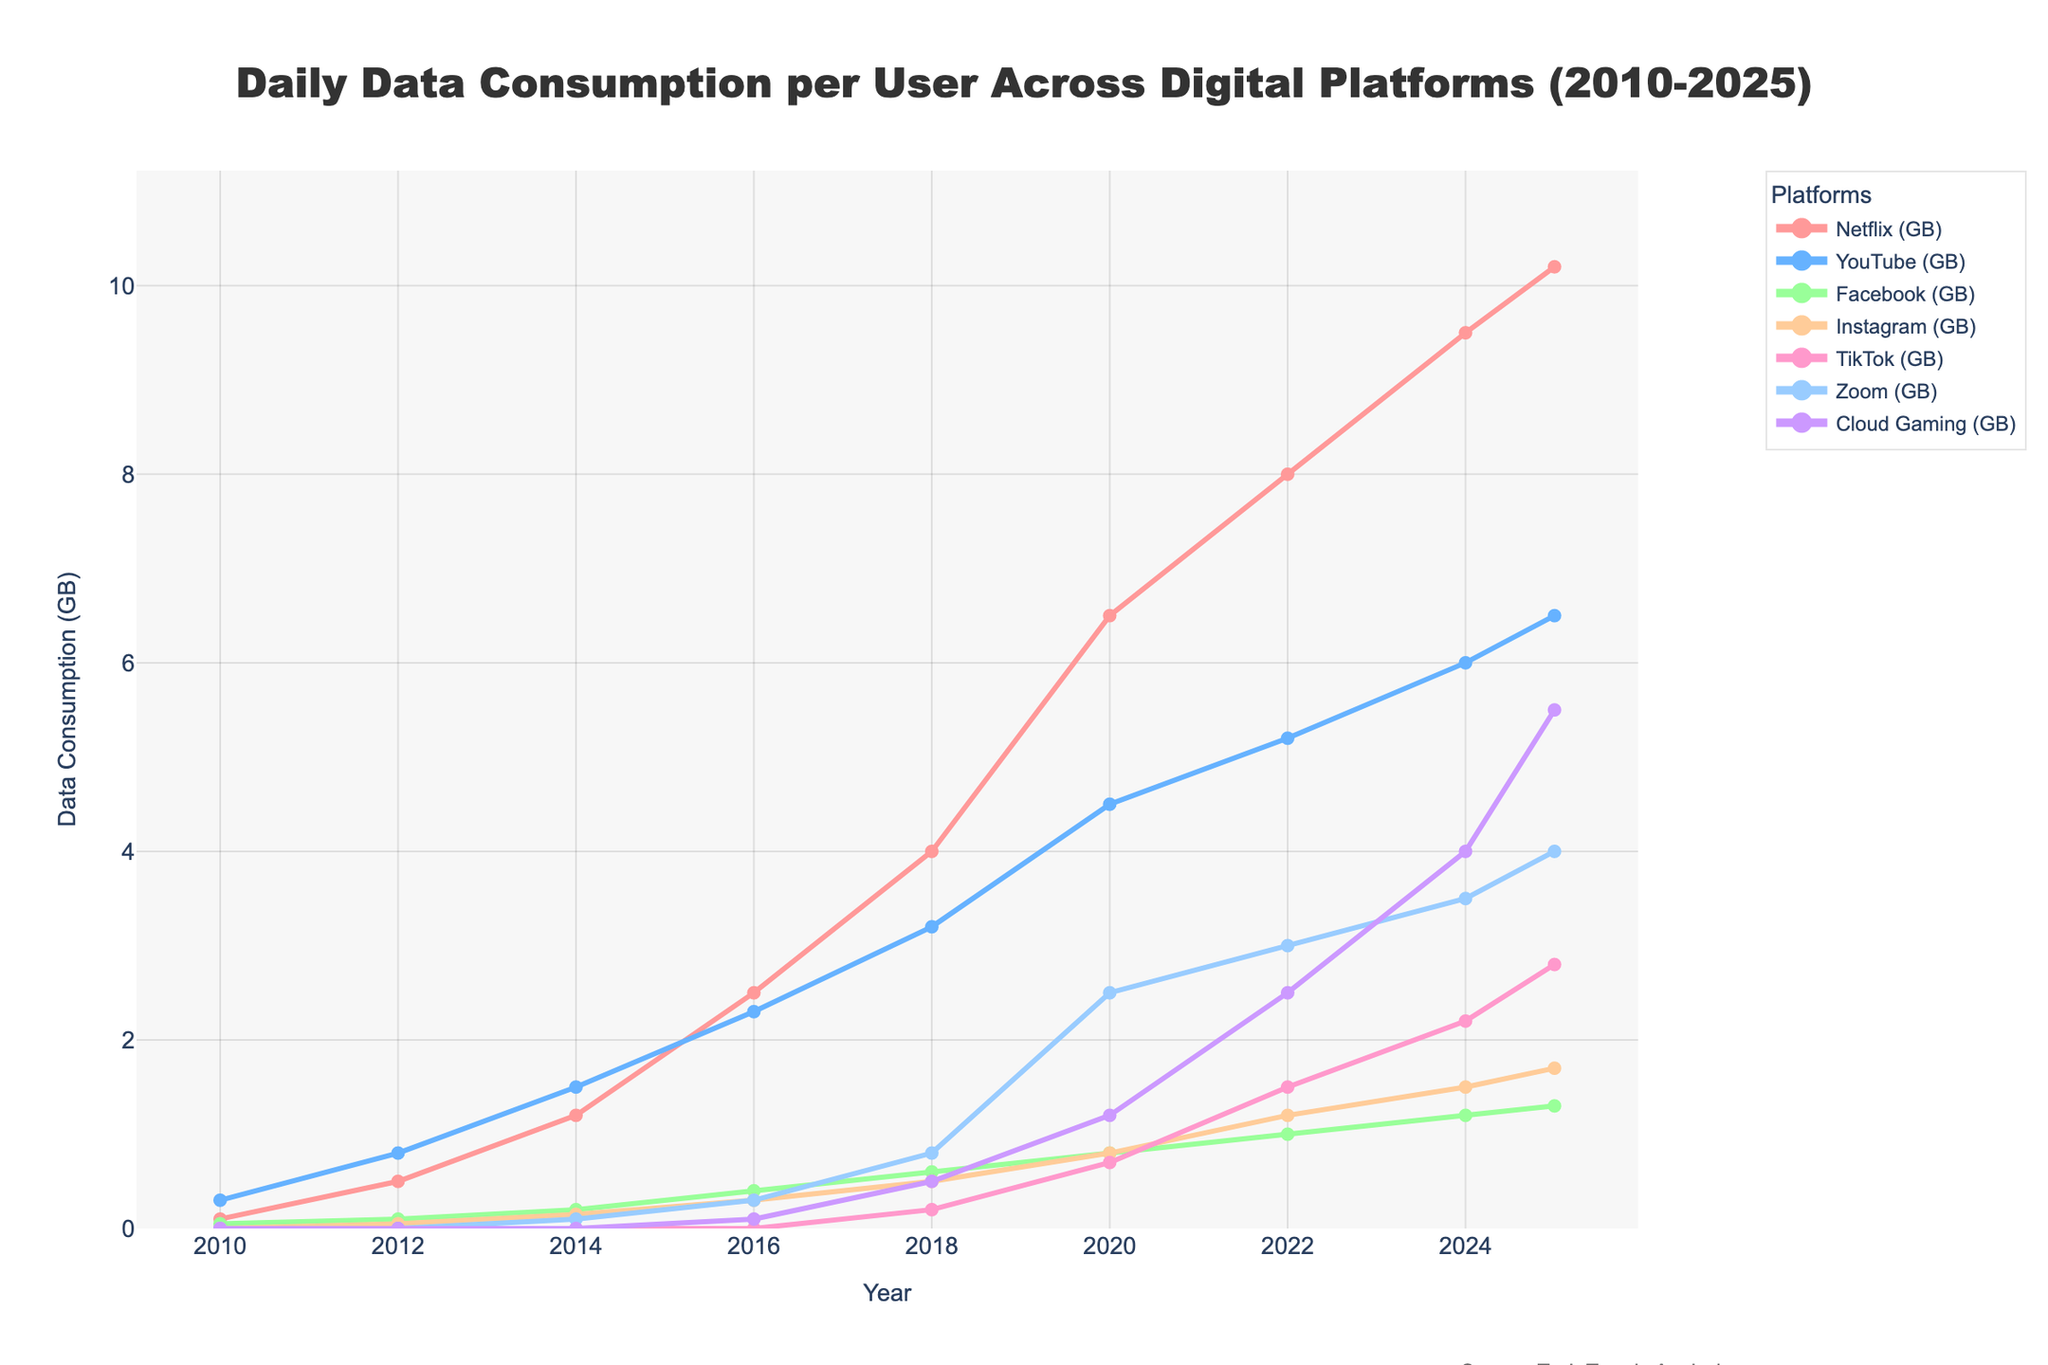What platform shows the highest increase in data consumption from 2010 to 2025? To find the platform with the highest increase, subtract the 2010 data consumption value from the 2025 value for each platform. Netflix: 10.2 - 0.1 = 10.1 GB, YouTube: 6.5 - 0.3 = 6.2 GB, Facebook: 1.3 - 0.05 = 1.25 GB, Instagram: 1.7 - 0 = 1.7 GB, TikTok: 2.8 - 0 = 2.8 GB, Zoom: 4.0 - 0 = 4.0 GB, Cloud Gaming: 5.5 - 0 = 5.5 GB. Netflix shows the highest increase (10.1 GB).
Answer: Netflix Which year saw the highest data consumption for YouTube prior to 2025? Refer to the YouTube data points for each year. The highest value before 2025 is 6.0 GB in 2024.
Answer: 2024 How does TikTok's data consumption in 2025 compare to Zoom's in 2020? TikTok's data consumption in 2025 is 2.8 GB and Zoom's in 2020 is 2.5 GB. 2.8 GB is greater than 2.5 GB.
Answer: TikTok's data consumption is higher What is the average data consumption growth per year for Cloud Gaming from 2016 to 2025? First, calculate the total growth: 5.5 GB (in 2025) - 0.1 GB (in 2016) = 5.4 GB. Next, find the number of years: 2025 - 2016 = 9 years. Finally, divide the total growth by the number of years: 5.4 GB / 9 years = 0.6 GB/year.
Answer: 0.6 GB/year During which year did Facebook's data consumption first exceed 0.5 GB? Look at Facebook's data points each year: Facebook's data consumption first exceeds 0.5 GB in 2018 (0.6 GB).
Answer: 2018 Compare the data consumption trends of Instagram and TikTok from 2014 to 2025. Instagram: 2014 - 0.15 GB, 2016 - 0.3 GB, 2018 - 0.5 GB, 2020 - 0.8 GB, 2022 - 1.2 GB, 2024 - 1.5 GB, 2025 - 1.7 GB. TikTok: 2014 - 0, 2016 - 0, 2018 - 0.2 GB, 2020 - 0.7 GB, 2022 - 1.5 GB, 2024 - 2.2 GB, 2025 - 2.8 GB. TikTok grows faster and surpasses Instagram in 2022.
Answer: TikTok grows faster and surpasses Instagram in 2022 Which platform had the smallest increase in data consumption from 2010 to 2012? Calculate the increase for each platform: Netflix: 0.5 - 0.1 = 0.4 GB, YouTube: 0.8 - 0.3 = 0.5 GB, Facebook: 0.1 - 0.05 = 0.05 GB, Instagram: 0.05 - 0 = 0.05 GB, TikTok: (0 remains 0), Zoom: (0 remains 0), Cloud Gaming: (0 remains 0). Facebook and Instagram have the smallest (0.05 GB).
Answer: Facebook and Instagram What is the cumulative data consumption for all platforms in 2020? Summing the data for all platforms in 2020: Netflix: 6.5 GB, YouTube: 4.5 GB, Facebook: 0.8 GB, Instagram: 0.8 GB, TikTok: 0.7 GB, Zoom: 2.5 GB, Cloud Gaming: 1.2 GB. Total: 6.5 + 4.5 + 0.8 + 0.8 + 0.7 + 2.5 + 1.2 = 17 GB.
Answer: 17 GB In which year did Cloud Gaming reach 2.5 GB of data consumption per user? Look at Cloud Gaming's data points: It reaches 2.5 GB in 2022.
Answer: 2022 